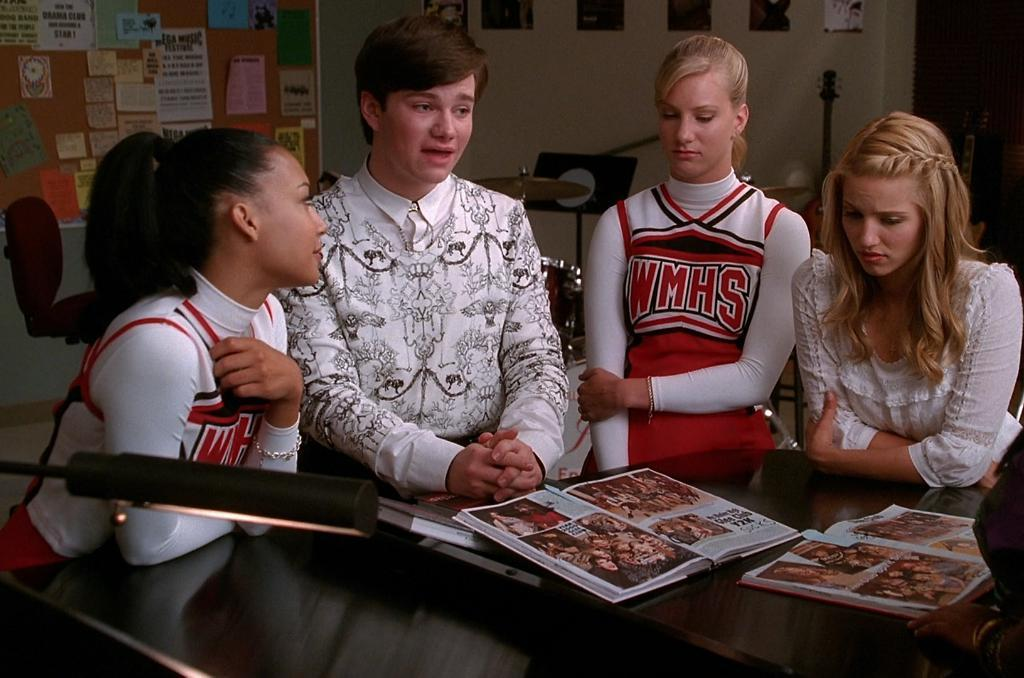<image>
Share a concise interpretation of the image provided. Some people around a table, one woman is wearing a shirt with WMHS on it. 